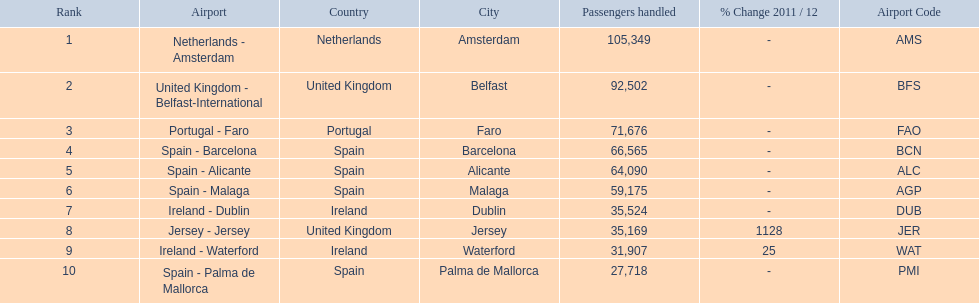What are the names of all the airports? Netherlands - Amsterdam, United Kingdom - Belfast-International, Portugal - Faro, Spain - Barcelona, Spain - Alicante, Spain - Malaga, Ireland - Dublin, Jersey - Jersey, Ireland - Waterford, Spain - Palma de Mallorca. Of these, what are all the passenger counts? 105,349, 92,502, 71,676, 66,565, 64,090, 59,175, 35,524, 35,169, 31,907, 27,718. Of these, which airport had more passengers than the united kingdom? Netherlands - Amsterdam. 